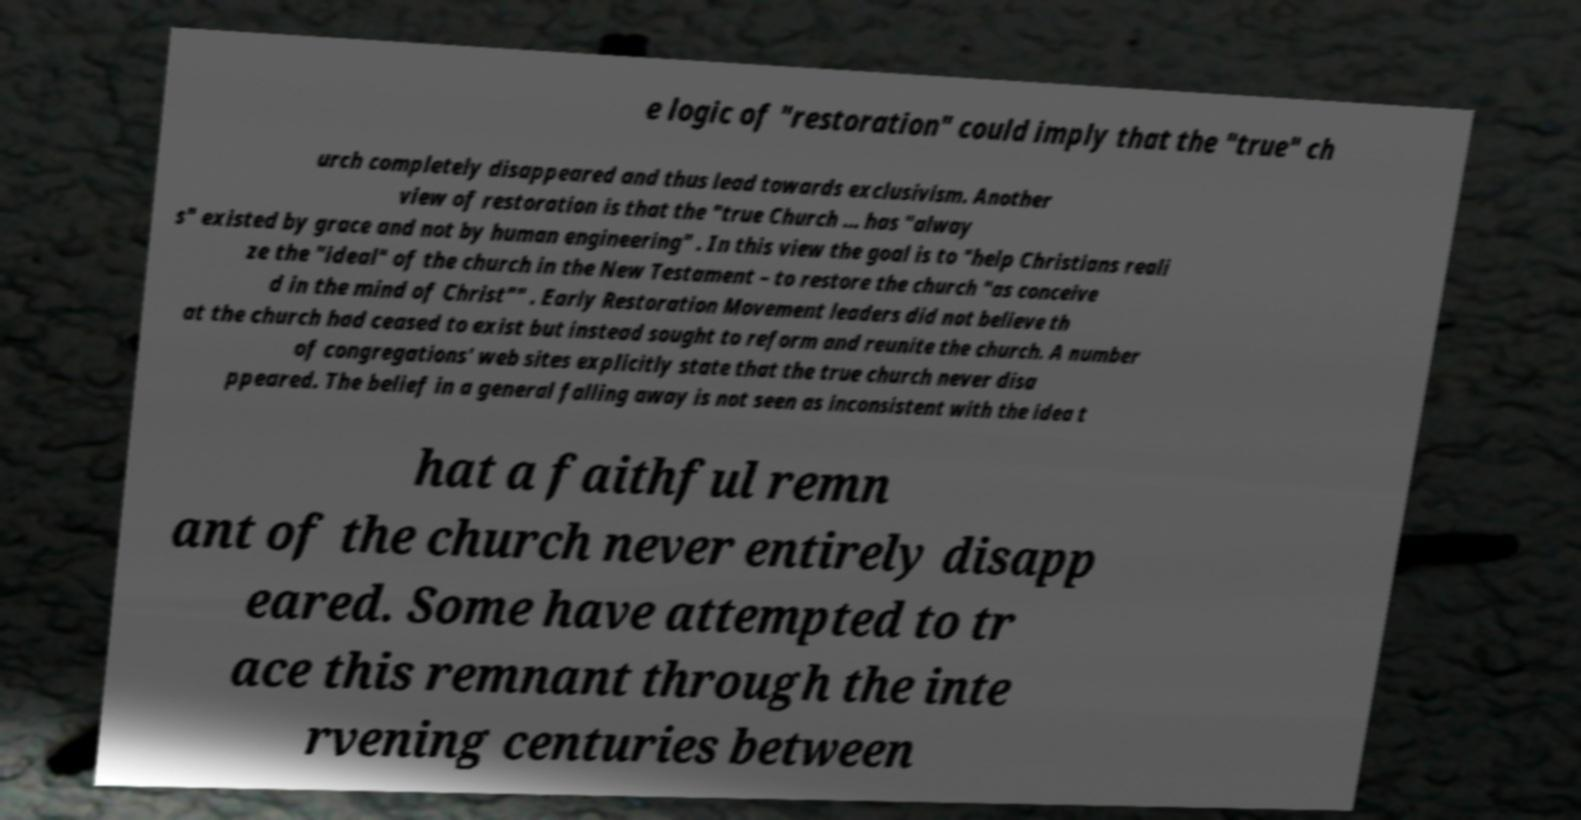Can you read and provide the text displayed in the image?This photo seems to have some interesting text. Can you extract and type it out for me? e logic of "restoration" could imply that the "true" ch urch completely disappeared and thus lead towards exclusivism. Another view of restoration is that the "true Church ... has "alway s" existed by grace and not by human engineering" . In this view the goal is to "help Christians reali ze the "ideal" of the church in the New Testament – to restore the church "as conceive d in the mind of Christ"" . Early Restoration Movement leaders did not believe th at the church had ceased to exist but instead sought to reform and reunite the church. A number of congregations' web sites explicitly state that the true church never disa ppeared. The belief in a general falling away is not seen as inconsistent with the idea t hat a faithful remn ant of the church never entirely disapp eared. Some have attempted to tr ace this remnant through the inte rvening centuries between 